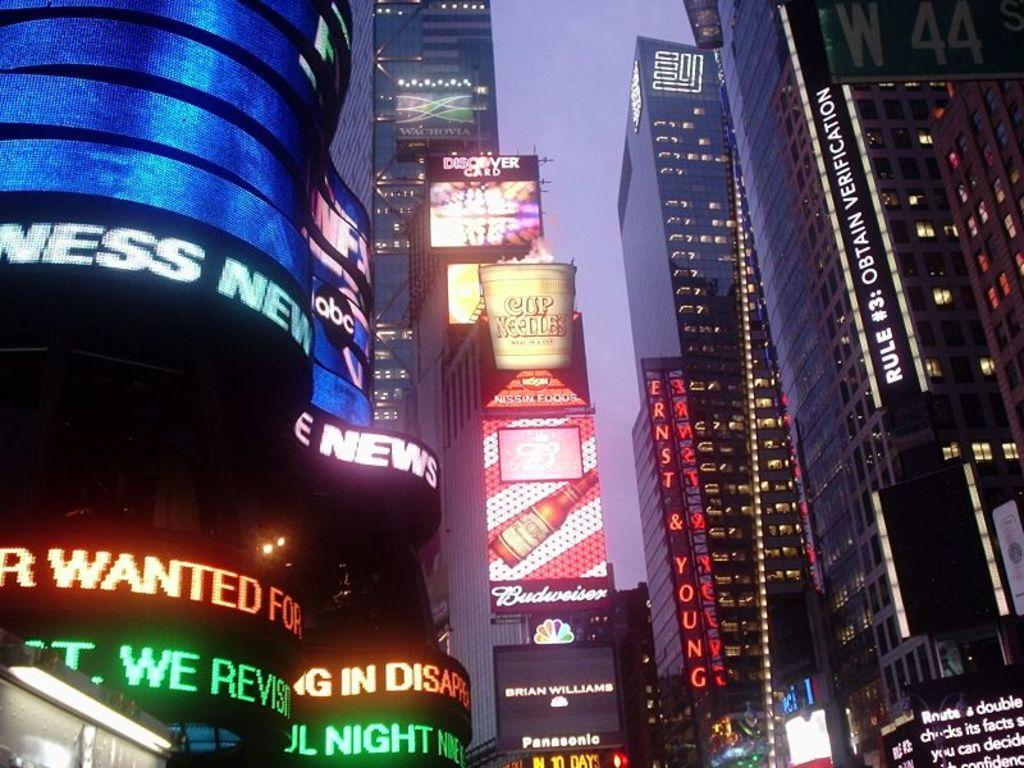What type of buildings are in the image? There are skyscrapers in the image. What feature do the skyscrapers have? The skyscrapers have lights. What is on the skyscrapers? There are scroll boards on the skyscrapers. What is visible in the background of the image? The sky is visible in the image. What type of milk is being served on the plate in the image? There is no milk or plate present in the image; it features skyscrapers with lights and scroll boards. What addition problem can be solved using the numbers on the scroll boards? There is no information about numbers on the scroll boards, so it is not possible to solve an addition problem based on the image. 